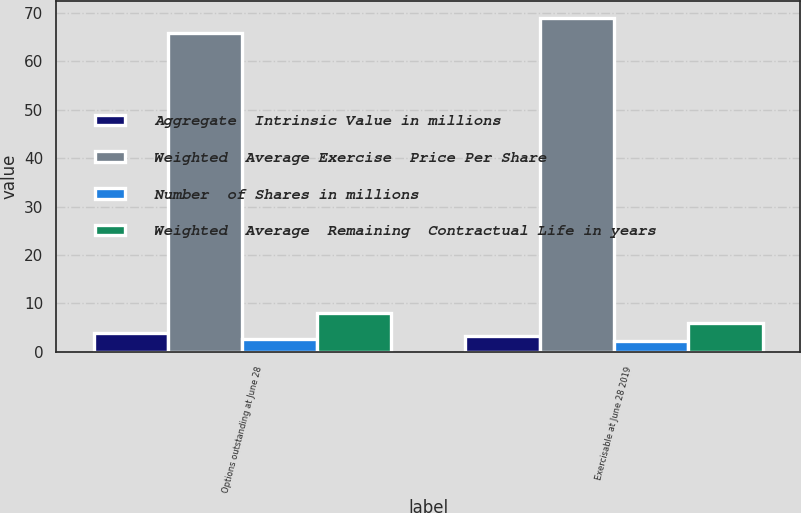Convert chart to OTSL. <chart><loc_0><loc_0><loc_500><loc_500><stacked_bar_chart><ecel><fcel>Options outstanding at June 28<fcel>Exercisable at June 28 2019<nl><fcel>Aggregate  Intrinsic Value in millions<fcel>3.9<fcel>3.3<nl><fcel>Weighted  Average Exercise  Price Per Share<fcel>65.72<fcel>68.97<nl><fcel>Number  of Shares in millions<fcel>2.6<fcel>2.3<nl><fcel>Weighted  Average  Remaining  Contractual Life in years<fcel>8<fcel>6<nl></chart> 